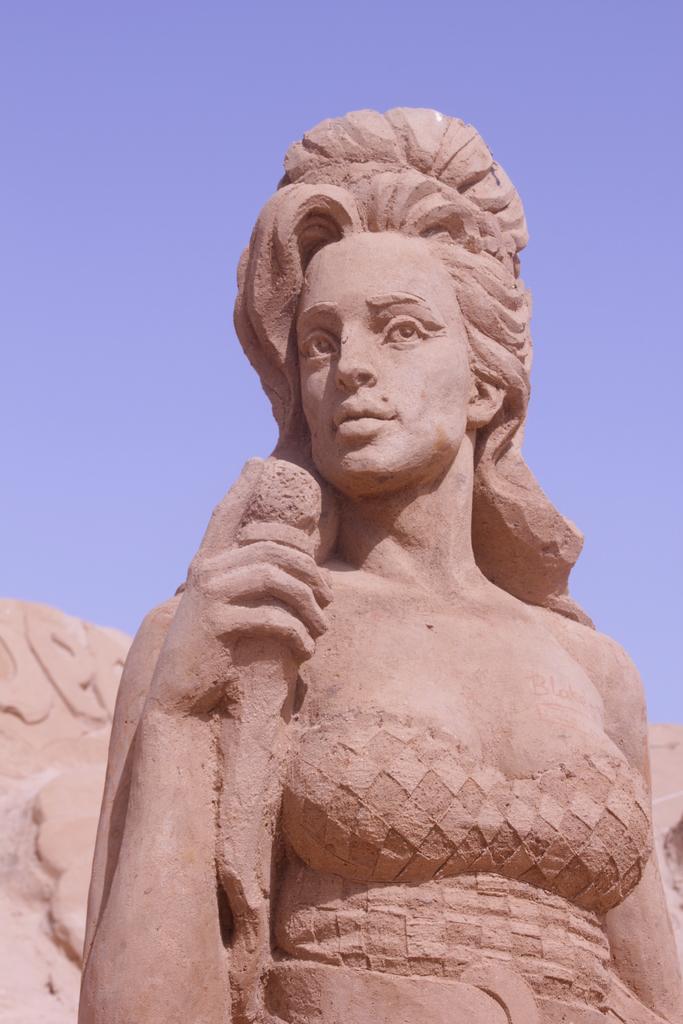Could you give a brief overview of what you see in this image? In this picture there is a sculpture in the center of the image. 